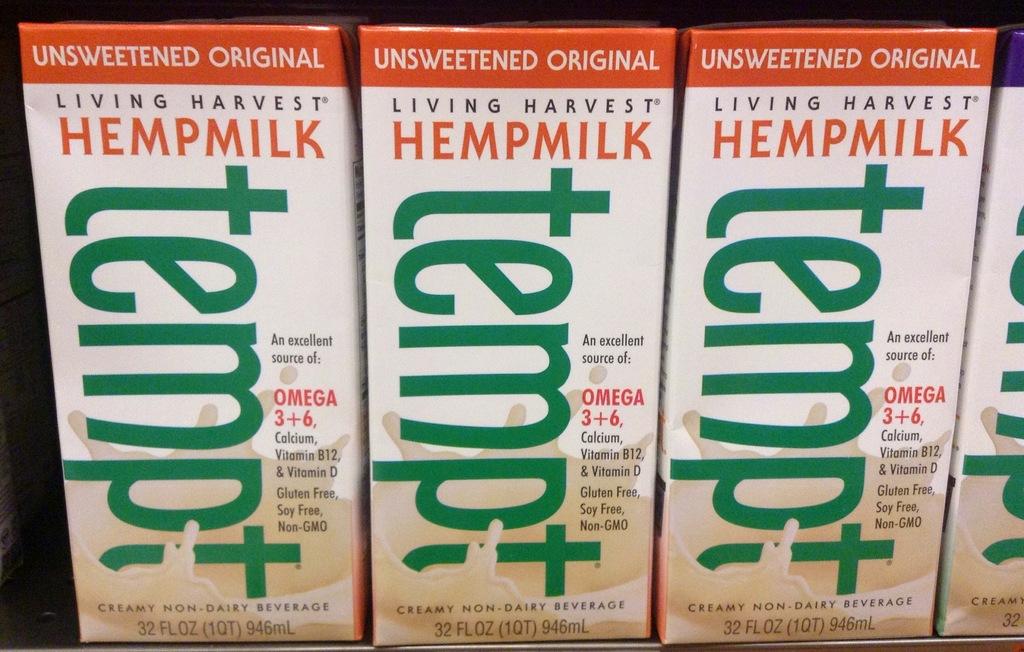Is this beverage sweetened?
Provide a succinct answer. No. What kind of milk is this?
Provide a short and direct response. Hempmilk. 